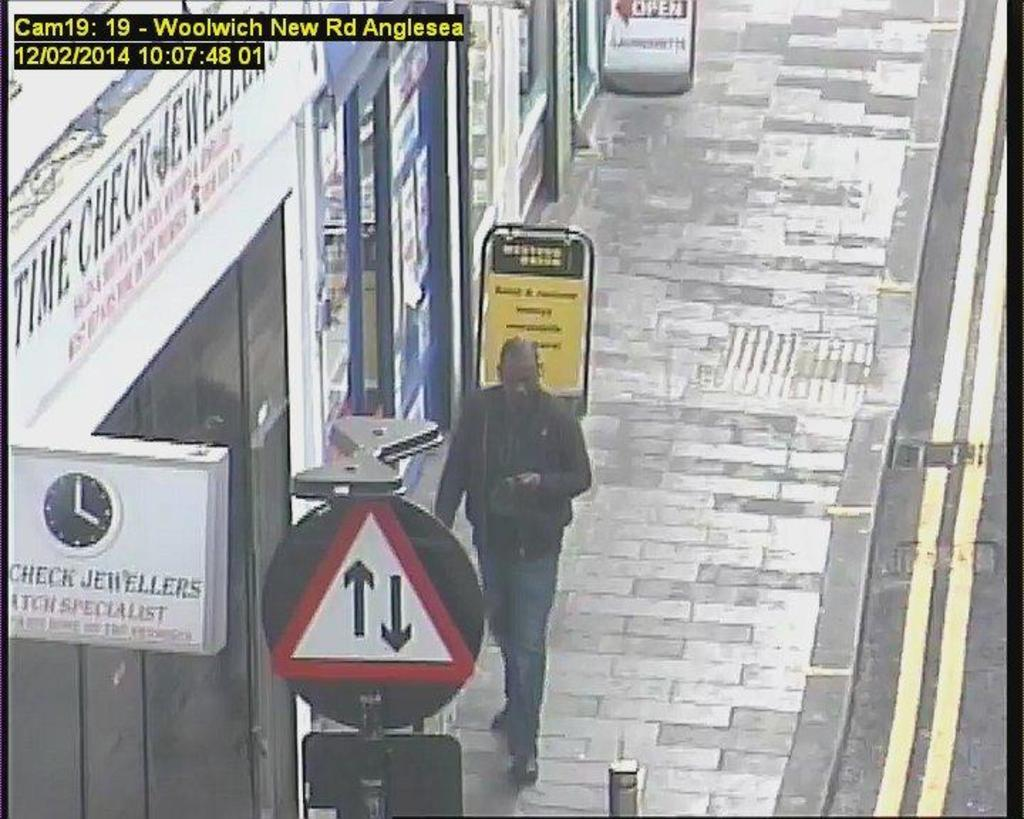Who is present in the image? There is a man in the image. What is the man doing in the image? The man is walking on a pathway in the image. What can be seen along the pathway? There are sign boards visible in the image. What type of establishments can be seen in the image? There are stores in the image. What type of cabbage is the man kicking in the image? There is no cabbage present in the image, nor is the man kicking anything. 